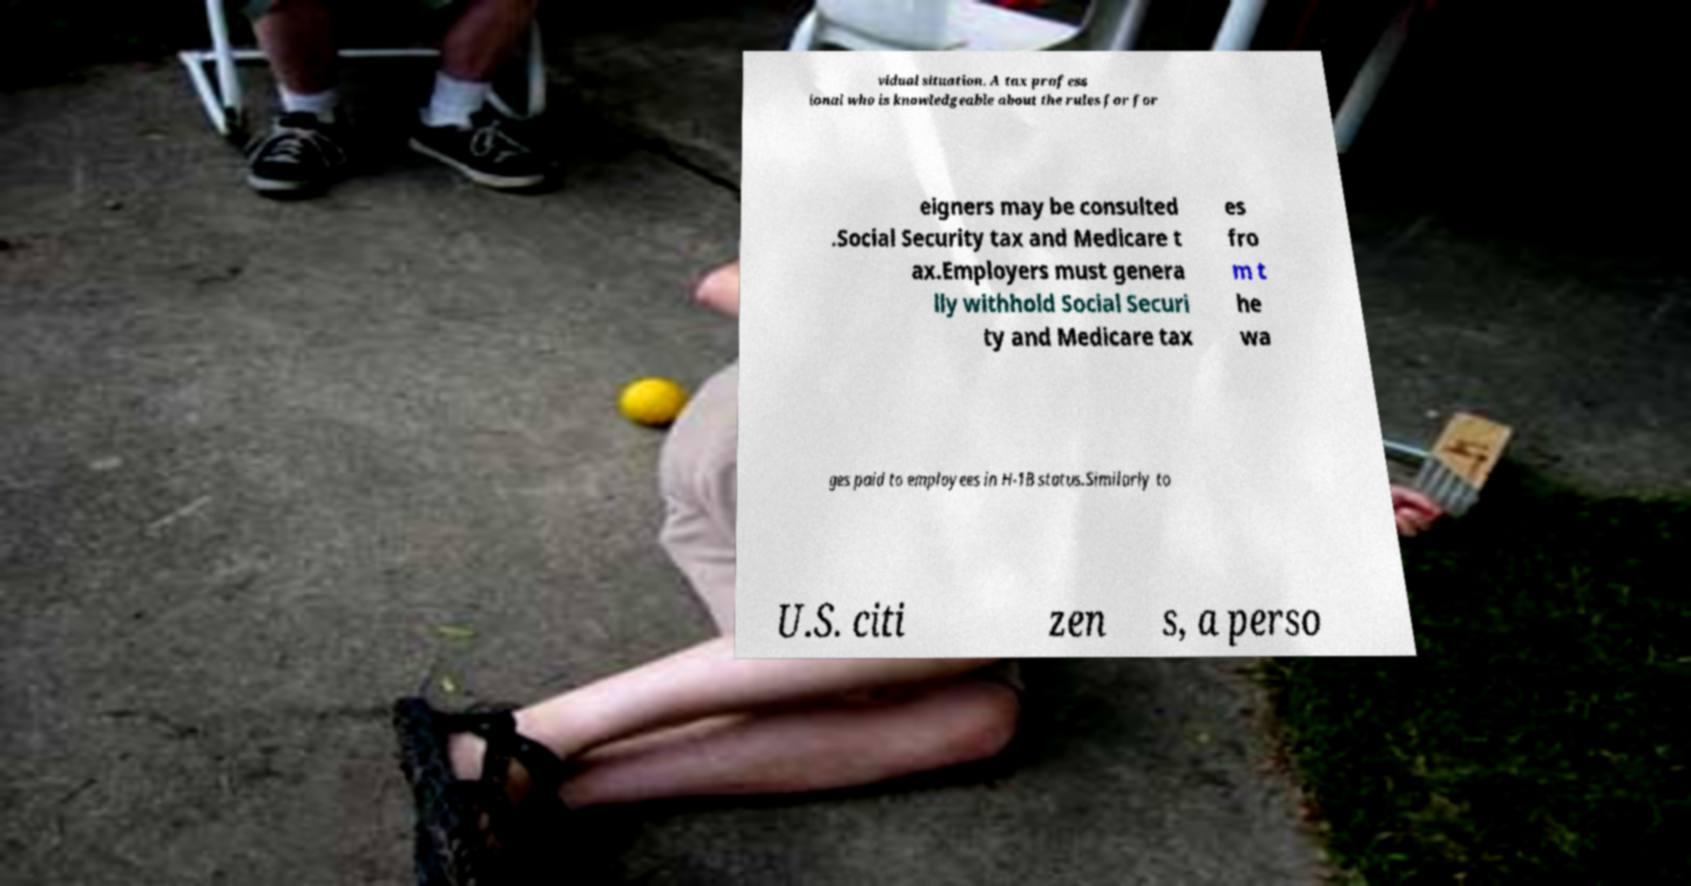Could you extract and type out the text from this image? vidual situation. A tax profess ional who is knowledgeable about the rules for for eigners may be consulted .Social Security tax and Medicare t ax.Employers must genera lly withhold Social Securi ty and Medicare tax es fro m t he wa ges paid to employees in H-1B status.Similarly to U.S. citi zen s, a perso 